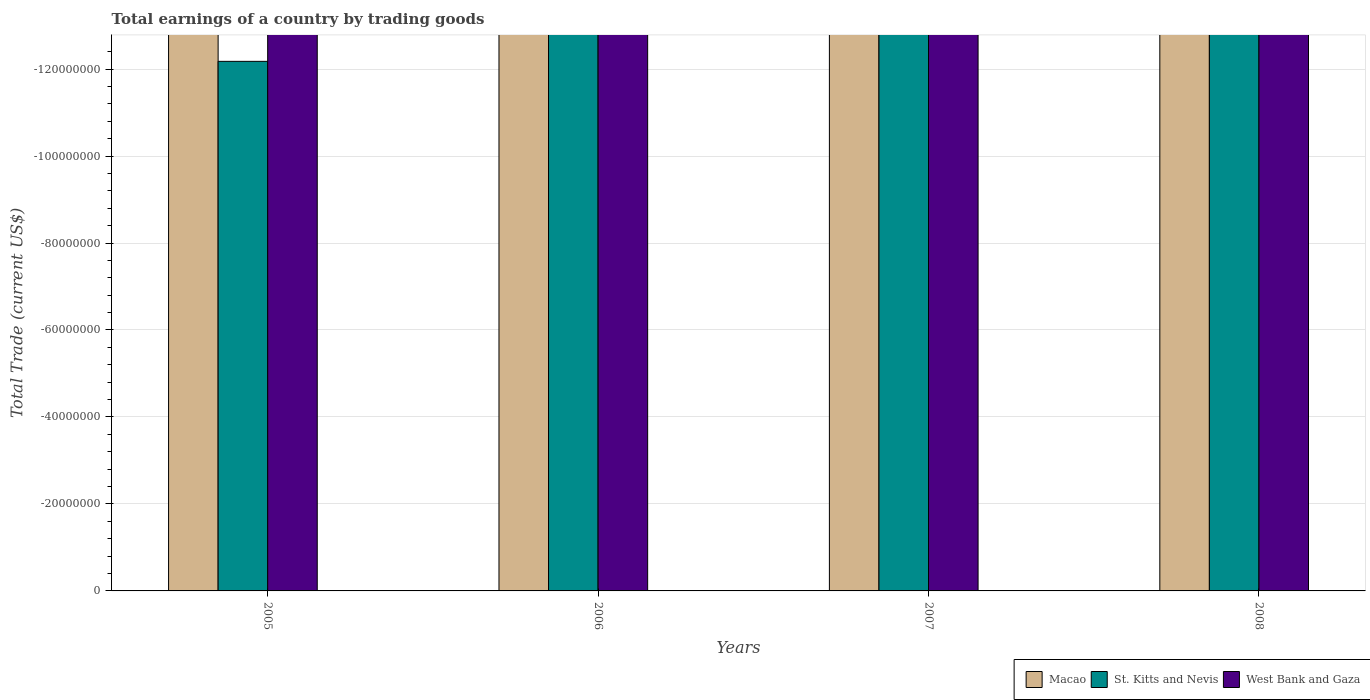Are the number of bars per tick equal to the number of legend labels?
Provide a short and direct response. No. What is the label of the 1st group of bars from the left?
Make the answer very short. 2005. In how many cases, is the number of bars for a given year not equal to the number of legend labels?
Your response must be concise. 4. What is the difference between the total earnings in St. Kitts and Nevis in 2007 and the total earnings in Macao in 2005?
Give a very brief answer. 0. What is the average total earnings in Macao per year?
Your answer should be very brief. 0. In how many years, is the total earnings in St. Kitts and Nevis greater than -116000000 US$?
Your answer should be compact. 0. In how many years, is the total earnings in West Bank and Gaza greater than the average total earnings in West Bank and Gaza taken over all years?
Make the answer very short. 0. How many bars are there?
Offer a very short reply. 0. How many years are there in the graph?
Ensure brevity in your answer.  4. What is the difference between two consecutive major ticks on the Y-axis?
Give a very brief answer. 2.00e+07. Does the graph contain any zero values?
Give a very brief answer. Yes. Does the graph contain grids?
Offer a terse response. Yes. Where does the legend appear in the graph?
Your answer should be compact. Bottom right. How are the legend labels stacked?
Make the answer very short. Horizontal. What is the title of the graph?
Give a very brief answer. Total earnings of a country by trading goods. Does "World" appear as one of the legend labels in the graph?
Provide a short and direct response. No. What is the label or title of the X-axis?
Your answer should be compact. Years. What is the label or title of the Y-axis?
Provide a succinct answer. Total Trade (current US$). What is the Total Trade (current US$) in West Bank and Gaza in 2005?
Your answer should be very brief. 0. What is the Total Trade (current US$) in West Bank and Gaza in 2006?
Give a very brief answer. 0. What is the Total Trade (current US$) of Macao in 2007?
Provide a short and direct response. 0. What is the Total Trade (current US$) in St. Kitts and Nevis in 2007?
Your answer should be compact. 0. What is the total Total Trade (current US$) in St. Kitts and Nevis in the graph?
Your answer should be compact. 0. 